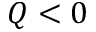<formula> <loc_0><loc_0><loc_500><loc_500>Q < 0</formula> 